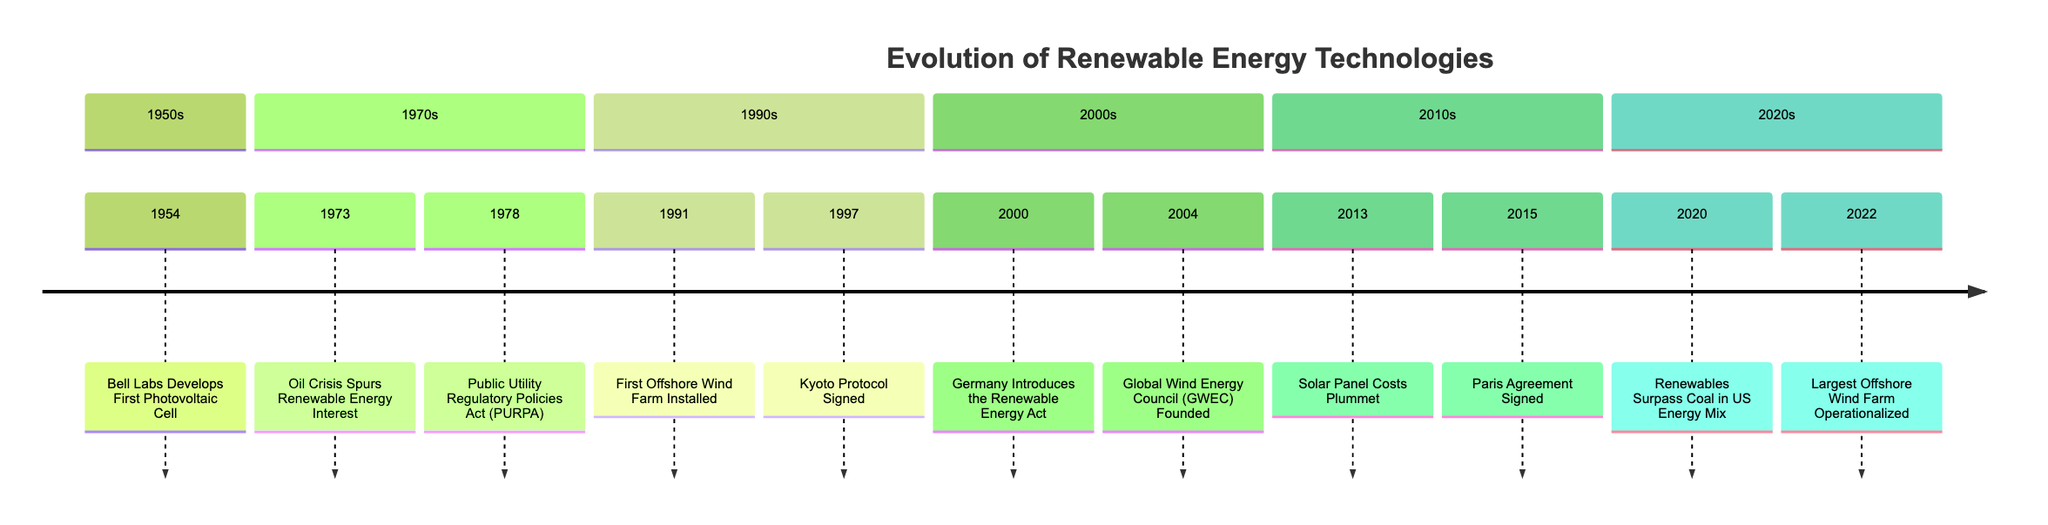What year was the first photovoltaic cell developed? The diagram indicates that the first photovoltaic cell was developed in 1954, as listed in the 1950s section.
Answer: 1954 What event occurred in 2004? The timeline shows that the Global Wind Energy Council (GWEC) was founded in 2004, which is specifically mentioned within the 2000s section.
Answer: Global Wind Energy Council (GWEC) Founded How many significant events are listed in the 1990s section? By counting the entries in the 1990s section of the timeline, there are two events: "First Offshore Wind Farm Installed" and "Kyoto Protocol Signed."
Answer: 2 Which event marks the first major milestone for offshore wind energy? The diagram states that the "First Offshore Wind Farm Installed" in 1991 is the event that marks a significant milestone specifically for offshore wind energy.
Answer: First Offshore Wind Farm Installed What was a significant development in renewable energy legislation in 2000? According to the timeline, the significant development in 2000 was Germany introducing the Renewable Energy Act, which focused on promoting renewable energy technologies.
Answer: Germany Introduces the Renewable Energy Act In which year did renewables surpass coal in the US energy mix? The timeline indicates that this milestone occurred in 2020, as highlighted in the 2020s section.
Answer: 2020 How many events occurred in the 2010s section? There are two events listed in the 2010s section: "Solar Panel Costs Plummet" and "Paris Agreement Signed," which can be counted directly from this section of the diagram.
Answer: 2 What international treaty was signed in 2015? The diagram states that the Paris Agreement was signed in 2015, reflecting a commitment to limit global warming.
Answer: Paris Agreement Signed What was the impact of the oil crisis in 1973 on renewable energy? The timeline notes that the oil crisis in 1973 spurred increased interest and investment in renewable energy sources as alternatives to fossil fuels.
Answer: Oil Crisis Spurs Renewable Energy Interest 